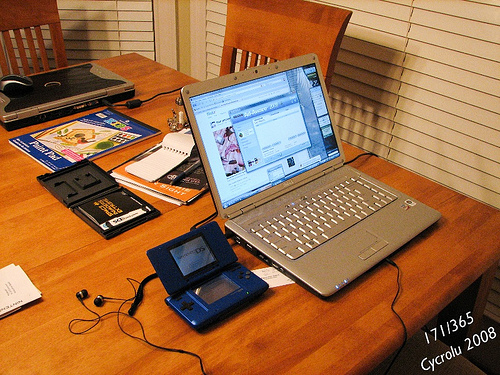<image>
Is there a laptop in front of the chair? Yes. The laptop is positioned in front of the chair, appearing closer to the camera viewpoint. 